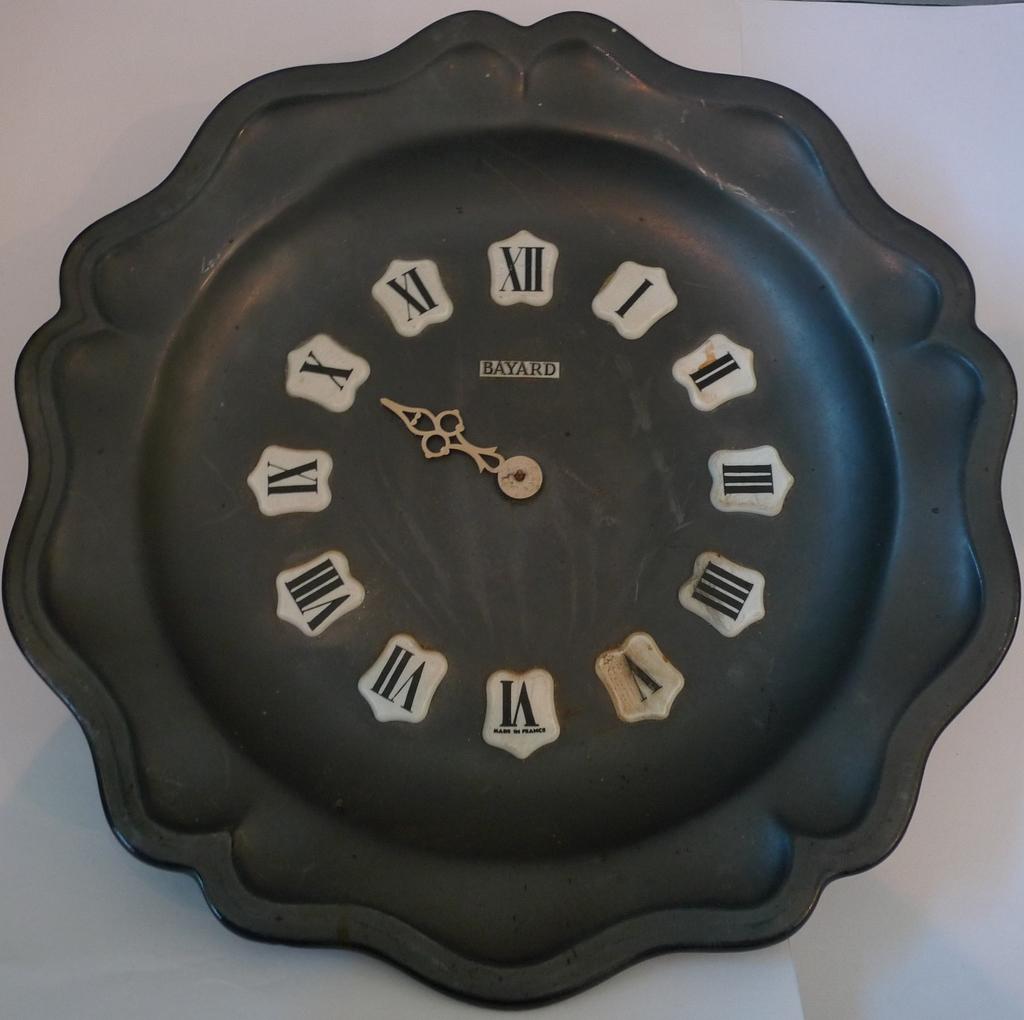What number is directly below the one the arrow is pointing to?
Give a very brief answer. 9. 